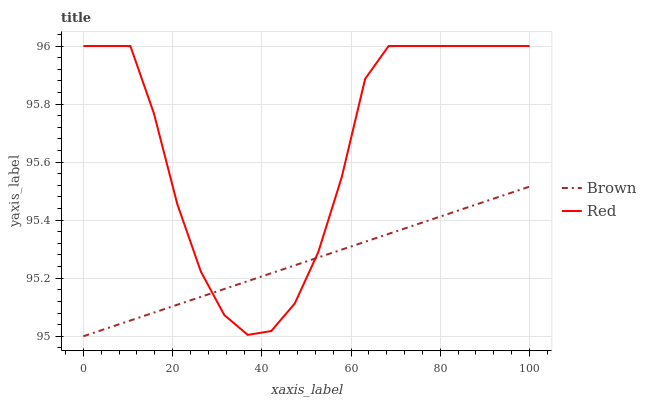Does Red have the minimum area under the curve?
Answer yes or no. No. Is Red the smoothest?
Answer yes or no. No. Does Red have the lowest value?
Answer yes or no. No. 